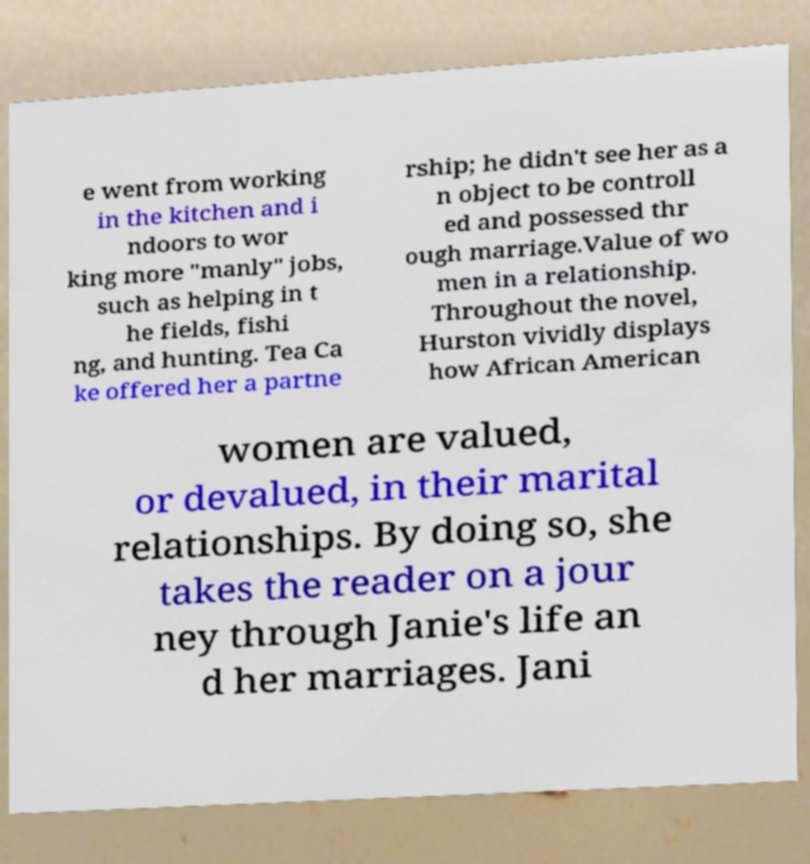Please read and relay the text visible in this image. What does it say? e went from working in the kitchen and i ndoors to wor king more "manly" jobs, such as helping in t he fields, fishi ng, and hunting. Tea Ca ke offered her a partne rship; he didn't see her as a n object to be controll ed and possessed thr ough marriage.Value of wo men in a relationship. Throughout the novel, Hurston vividly displays how African American women are valued, or devalued, in their marital relationships. By doing so, she takes the reader on a jour ney through Janie's life an d her marriages. Jani 